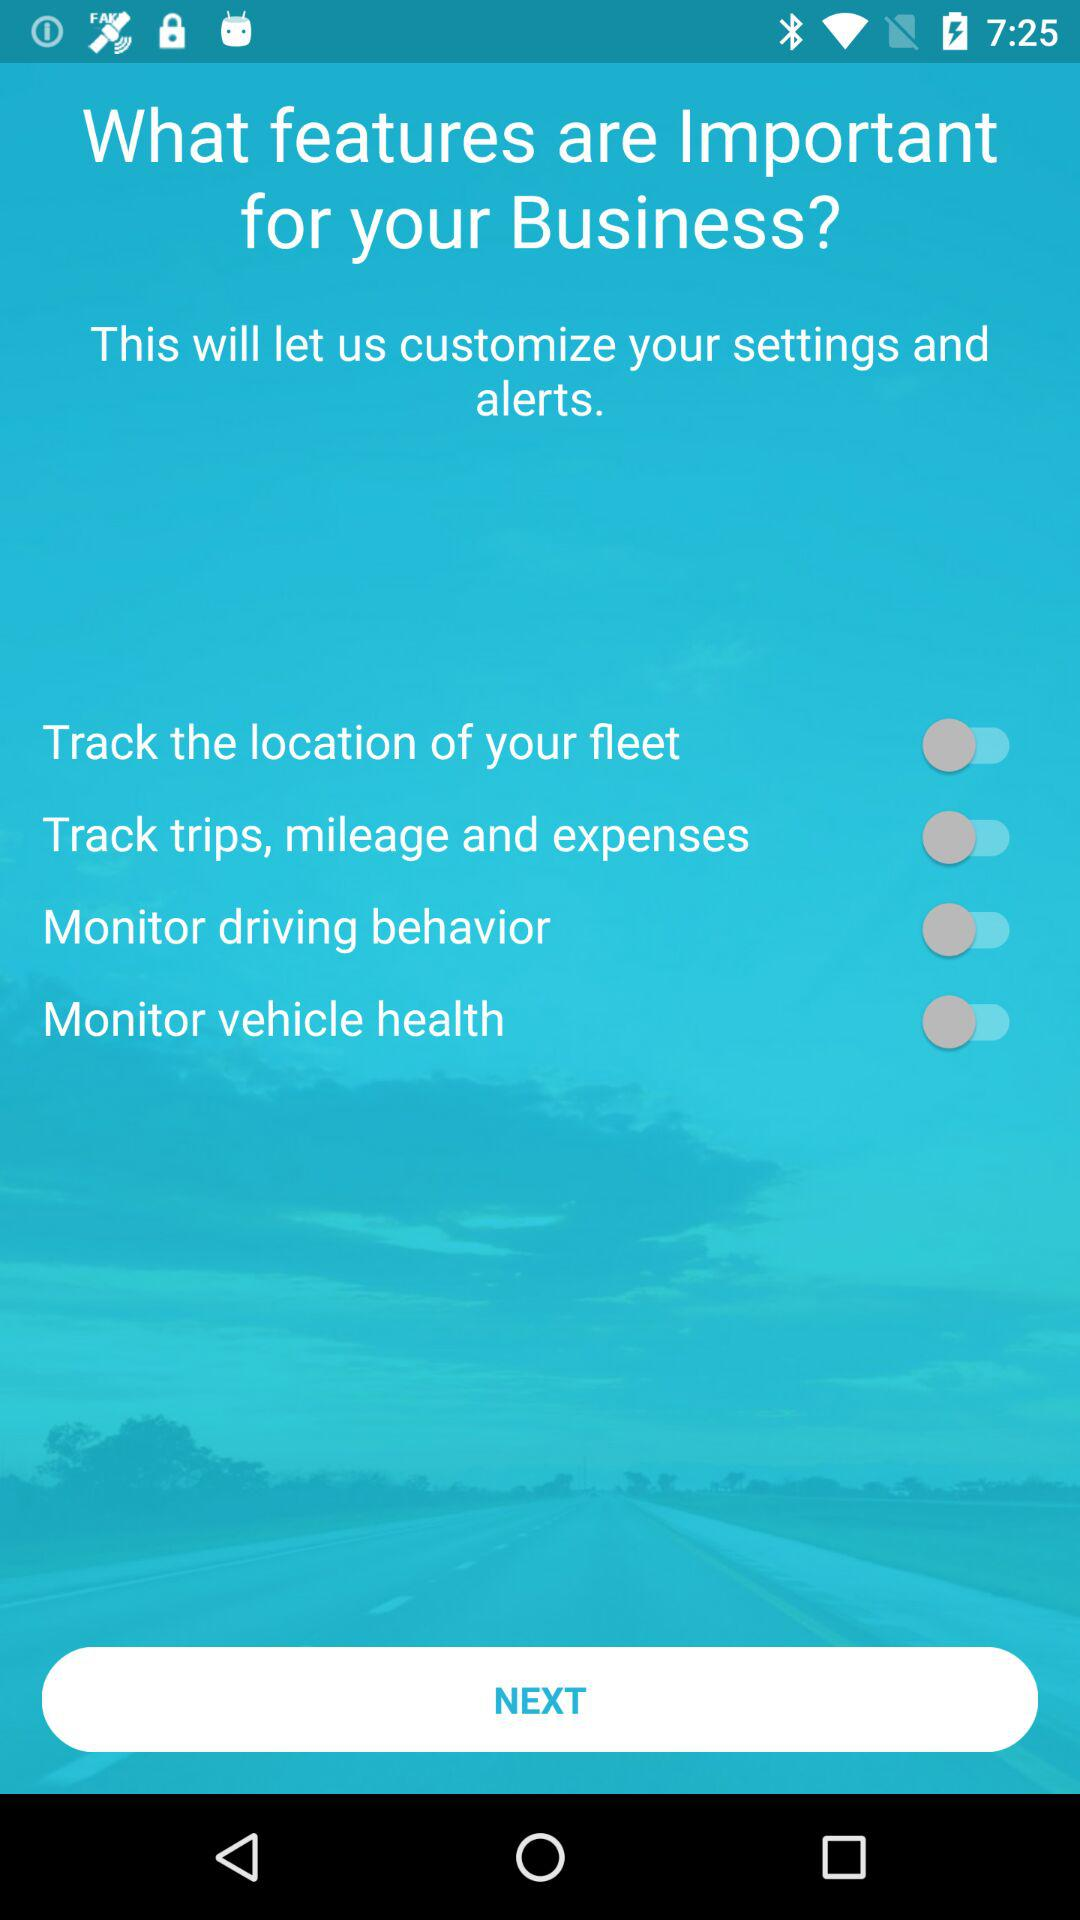What is the status of the "Monitor vehicle health" setting? The setting is off. 